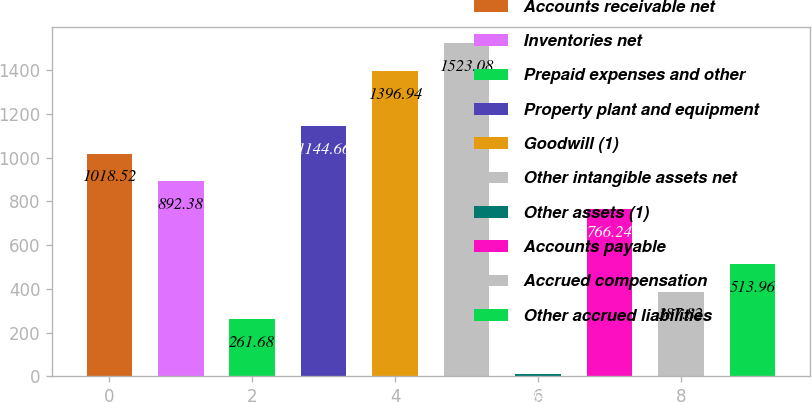<chart> <loc_0><loc_0><loc_500><loc_500><bar_chart><fcel>Accounts receivable net<fcel>Inventories net<fcel>Prepaid expenses and other<fcel>Property plant and equipment<fcel>Goodwill (1)<fcel>Other intangible assets net<fcel>Other assets (1)<fcel>Accounts payable<fcel>Accrued compensation<fcel>Other accrued liabilities<nl><fcel>1018.52<fcel>892.38<fcel>261.68<fcel>1144.66<fcel>1396.94<fcel>1523.08<fcel>9.4<fcel>766.24<fcel>387.82<fcel>513.96<nl></chart> 